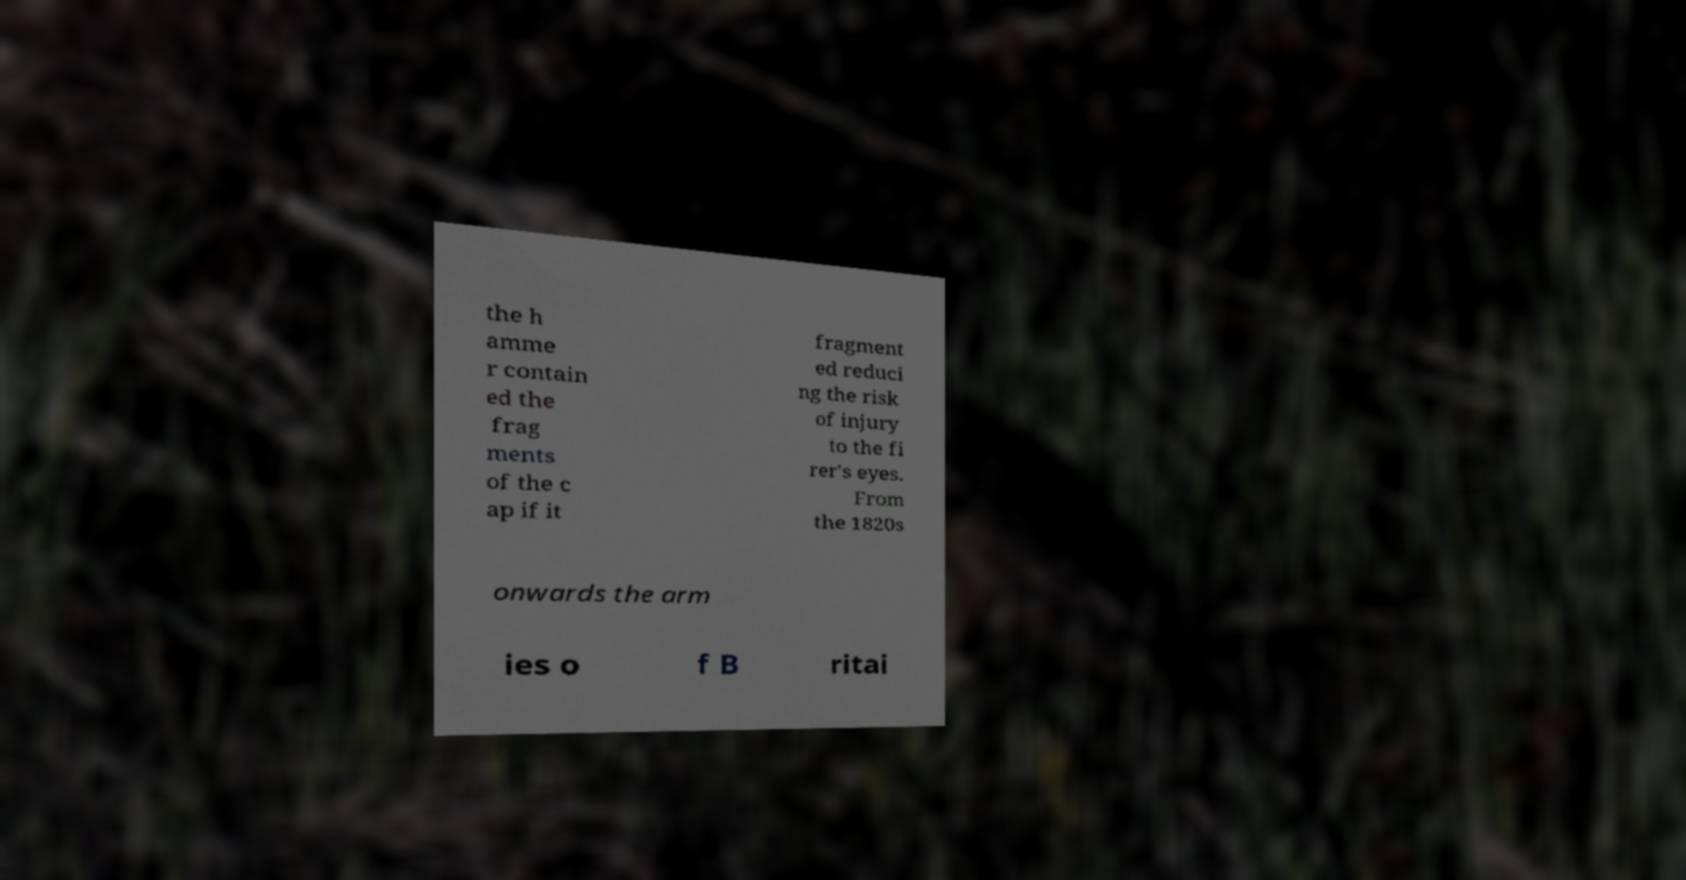Can you read and provide the text displayed in the image?This photo seems to have some interesting text. Can you extract and type it out for me? the h amme r contain ed the frag ments of the c ap if it fragment ed reduci ng the risk of injury to the fi rer's eyes. From the 1820s onwards the arm ies o f B ritai 